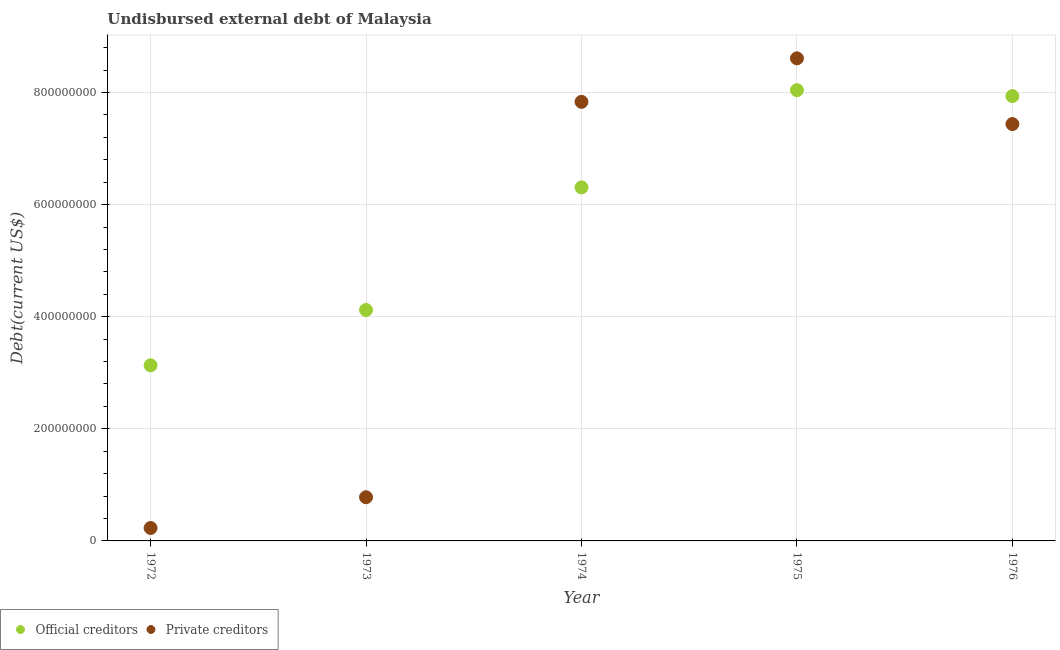Is the number of dotlines equal to the number of legend labels?
Keep it short and to the point. Yes. What is the undisbursed external debt of private creditors in 1974?
Make the answer very short. 7.83e+08. Across all years, what is the maximum undisbursed external debt of official creditors?
Provide a short and direct response. 8.04e+08. Across all years, what is the minimum undisbursed external debt of private creditors?
Keep it short and to the point. 2.31e+07. In which year was the undisbursed external debt of private creditors maximum?
Ensure brevity in your answer.  1975. In which year was the undisbursed external debt of private creditors minimum?
Provide a succinct answer. 1972. What is the total undisbursed external debt of official creditors in the graph?
Ensure brevity in your answer.  2.95e+09. What is the difference between the undisbursed external debt of official creditors in 1972 and that in 1975?
Ensure brevity in your answer.  -4.91e+08. What is the difference between the undisbursed external debt of official creditors in 1974 and the undisbursed external debt of private creditors in 1976?
Ensure brevity in your answer.  -1.13e+08. What is the average undisbursed external debt of official creditors per year?
Offer a terse response. 5.91e+08. In the year 1973, what is the difference between the undisbursed external debt of private creditors and undisbursed external debt of official creditors?
Your answer should be very brief. -3.34e+08. What is the ratio of the undisbursed external debt of official creditors in 1972 to that in 1975?
Keep it short and to the point. 0.39. Is the difference between the undisbursed external debt of official creditors in 1973 and 1975 greater than the difference between the undisbursed external debt of private creditors in 1973 and 1975?
Ensure brevity in your answer.  Yes. What is the difference between the highest and the second highest undisbursed external debt of official creditors?
Your response must be concise. 1.06e+07. What is the difference between the highest and the lowest undisbursed external debt of official creditors?
Offer a very short reply. 4.91e+08. In how many years, is the undisbursed external debt of private creditors greater than the average undisbursed external debt of private creditors taken over all years?
Make the answer very short. 3. Is the sum of the undisbursed external debt of official creditors in 1975 and 1976 greater than the maximum undisbursed external debt of private creditors across all years?
Offer a very short reply. Yes. Does the undisbursed external debt of private creditors monotonically increase over the years?
Provide a short and direct response. No. Is the undisbursed external debt of private creditors strictly less than the undisbursed external debt of official creditors over the years?
Offer a terse response. No. How many dotlines are there?
Offer a very short reply. 2. What is the difference between two consecutive major ticks on the Y-axis?
Your response must be concise. 2.00e+08. Does the graph contain grids?
Make the answer very short. Yes. How many legend labels are there?
Your answer should be very brief. 2. What is the title of the graph?
Provide a succinct answer. Undisbursed external debt of Malaysia. What is the label or title of the Y-axis?
Ensure brevity in your answer.  Debt(current US$). What is the Debt(current US$) in Official creditors in 1972?
Your answer should be very brief. 3.13e+08. What is the Debt(current US$) of Private creditors in 1972?
Provide a succinct answer. 2.31e+07. What is the Debt(current US$) in Official creditors in 1973?
Provide a short and direct response. 4.12e+08. What is the Debt(current US$) in Private creditors in 1973?
Your answer should be very brief. 7.79e+07. What is the Debt(current US$) of Official creditors in 1974?
Your response must be concise. 6.31e+08. What is the Debt(current US$) in Private creditors in 1974?
Provide a short and direct response. 7.83e+08. What is the Debt(current US$) in Official creditors in 1975?
Offer a terse response. 8.04e+08. What is the Debt(current US$) in Private creditors in 1975?
Your answer should be very brief. 8.61e+08. What is the Debt(current US$) in Official creditors in 1976?
Ensure brevity in your answer.  7.94e+08. What is the Debt(current US$) of Private creditors in 1976?
Offer a terse response. 7.44e+08. Across all years, what is the maximum Debt(current US$) of Official creditors?
Offer a terse response. 8.04e+08. Across all years, what is the maximum Debt(current US$) of Private creditors?
Keep it short and to the point. 8.61e+08. Across all years, what is the minimum Debt(current US$) of Official creditors?
Make the answer very short. 3.13e+08. Across all years, what is the minimum Debt(current US$) of Private creditors?
Ensure brevity in your answer.  2.31e+07. What is the total Debt(current US$) in Official creditors in the graph?
Make the answer very short. 2.95e+09. What is the total Debt(current US$) in Private creditors in the graph?
Make the answer very short. 2.49e+09. What is the difference between the Debt(current US$) of Official creditors in 1972 and that in 1973?
Ensure brevity in your answer.  -9.87e+07. What is the difference between the Debt(current US$) of Private creditors in 1972 and that in 1973?
Keep it short and to the point. -5.49e+07. What is the difference between the Debt(current US$) in Official creditors in 1972 and that in 1974?
Make the answer very short. -3.18e+08. What is the difference between the Debt(current US$) of Private creditors in 1972 and that in 1974?
Give a very brief answer. -7.60e+08. What is the difference between the Debt(current US$) in Official creditors in 1972 and that in 1975?
Provide a succinct answer. -4.91e+08. What is the difference between the Debt(current US$) of Private creditors in 1972 and that in 1975?
Ensure brevity in your answer.  -8.38e+08. What is the difference between the Debt(current US$) in Official creditors in 1972 and that in 1976?
Your answer should be very brief. -4.80e+08. What is the difference between the Debt(current US$) in Private creditors in 1972 and that in 1976?
Offer a terse response. -7.21e+08. What is the difference between the Debt(current US$) of Official creditors in 1973 and that in 1974?
Provide a succinct answer. -2.19e+08. What is the difference between the Debt(current US$) in Private creditors in 1973 and that in 1974?
Give a very brief answer. -7.06e+08. What is the difference between the Debt(current US$) in Official creditors in 1973 and that in 1975?
Provide a short and direct response. -3.92e+08. What is the difference between the Debt(current US$) of Private creditors in 1973 and that in 1975?
Ensure brevity in your answer.  -7.83e+08. What is the difference between the Debt(current US$) in Official creditors in 1973 and that in 1976?
Offer a very short reply. -3.82e+08. What is the difference between the Debt(current US$) in Private creditors in 1973 and that in 1976?
Your response must be concise. -6.66e+08. What is the difference between the Debt(current US$) in Official creditors in 1974 and that in 1975?
Keep it short and to the point. -1.73e+08. What is the difference between the Debt(current US$) in Private creditors in 1974 and that in 1975?
Your answer should be compact. -7.76e+07. What is the difference between the Debt(current US$) in Official creditors in 1974 and that in 1976?
Ensure brevity in your answer.  -1.63e+08. What is the difference between the Debt(current US$) in Private creditors in 1974 and that in 1976?
Give a very brief answer. 3.96e+07. What is the difference between the Debt(current US$) of Official creditors in 1975 and that in 1976?
Make the answer very short. 1.06e+07. What is the difference between the Debt(current US$) in Private creditors in 1975 and that in 1976?
Offer a terse response. 1.17e+08. What is the difference between the Debt(current US$) of Official creditors in 1972 and the Debt(current US$) of Private creditors in 1973?
Your response must be concise. 2.35e+08. What is the difference between the Debt(current US$) in Official creditors in 1972 and the Debt(current US$) in Private creditors in 1974?
Your answer should be very brief. -4.70e+08. What is the difference between the Debt(current US$) in Official creditors in 1972 and the Debt(current US$) in Private creditors in 1975?
Provide a short and direct response. -5.48e+08. What is the difference between the Debt(current US$) in Official creditors in 1972 and the Debt(current US$) in Private creditors in 1976?
Make the answer very short. -4.30e+08. What is the difference between the Debt(current US$) of Official creditors in 1973 and the Debt(current US$) of Private creditors in 1974?
Make the answer very short. -3.71e+08. What is the difference between the Debt(current US$) of Official creditors in 1973 and the Debt(current US$) of Private creditors in 1975?
Your answer should be very brief. -4.49e+08. What is the difference between the Debt(current US$) of Official creditors in 1973 and the Debt(current US$) of Private creditors in 1976?
Your answer should be compact. -3.32e+08. What is the difference between the Debt(current US$) of Official creditors in 1974 and the Debt(current US$) of Private creditors in 1975?
Provide a short and direct response. -2.30e+08. What is the difference between the Debt(current US$) in Official creditors in 1974 and the Debt(current US$) in Private creditors in 1976?
Ensure brevity in your answer.  -1.13e+08. What is the difference between the Debt(current US$) in Official creditors in 1975 and the Debt(current US$) in Private creditors in 1976?
Your answer should be very brief. 6.05e+07. What is the average Debt(current US$) in Official creditors per year?
Your answer should be very brief. 5.91e+08. What is the average Debt(current US$) of Private creditors per year?
Provide a succinct answer. 4.98e+08. In the year 1972, what is the difference between the Debt(current US$) in Official creditors and Debt(current US$) in Private creditors?
Your answer should be compact. 2.90e+08. In the year 1973, what is the difference between the Debt(current US$) of Official creditors and Debt(current US$) of Private creditors?
Give a very brief answer. 3.34e+08. In the year 1974, what is the difference between the Debt(current US$) of Official creditors and Debt(current US$) of Private creditors?
Your response must be concise. -1.53e+08. In the year 1975, what is the difference between the Debt(current US$) in Official creditors and Debt(current US$) in Private creditors?
Ensure brevity in your answer.  -5.68e+07. In the year 1976, what is the difference between the Debt(current US$) of Official creditors and Debt(current US$) of Private creditors?
Make the answer very short. 4.99e+07. What is the ratio of the Debt(current US$) of Official creditors in 1972 to that in 1973?
Keep it short and to the point. 0.76. What is the ratio of the Debt(current US$) in Private creditors in 1972 to that in 1973?
Offer a terse response. 0.3. What is the ratio of the Debt(current US$) in Official creditors in 1972 to that in 1974?
Provide a short and direct response. 0.5. What is the ratio of the Debt(current US$) in Private creditors in 1972 to that in 1974?
Your answer should be compact. 0.03. What is the ratio of the Debt(current US$) of Official creditors in 1972 to that in 1975?
Your response must be concise. 0.39. What is the ratio of the Debt(current US$) in Private creditors in 1972 to that in 1975?
Give a very brief answer. 0.03. What is the ratio of the Debt(current US$) in Official creditors in 1972 to that in 1976?
Your answer should be very brief. 0.39. What is the ratio of the Debt(current US$) of Private creditors in 1972 to that in 1976?
Give a very brief answer. 0.03. What is the ratio of the Debt(current US$) in Official creditors in 1973 to that in 1974?
Your answer should be very brief. 0.65. What is the ratio of the Debt(current US$) of Private creditors in 1973 to that in 1974?
Ensure brevity in your answer.  0.1. What is the ratio of the Debt(current US$) of Official creditors in 1973 to that in 1975?
Your answer should be very brief. 0.51. What is the ratio of the Debt(current US$) of Private creditors in 1973 to that in 1975?
Offer a very short reply. 0.09. What is the ratio of the Debt(current US$) of Official creditors in 1973 to that in 1976?
Keep it short and to the point. 0.52. What is the ratio of the Debt(current US$) in Private creditors in 1973 to that in 1976?
Your answer should be compact. 0.1. What is the ratio of the Debt(current US$) of Official creditors in 1974 to that in 1975?
Your answer should be very brief. 0.78. What is the ratio of the Debt(current US$) of Private creditors in 1974 to that in 1975?
Your response must be concise. 0.91. What is the ratio of the Debt(current US$) in Official creditors in 1974 to that in 1976?
Offer a very short reply. 0.79. What is the ratio of the Debt(current US$) of Private creditors in 1974 to that in 1976?
Your response must be concise. 1.05. What is the ratio of the Debt(current US$) in Official creditors in 1975 to that in 1976?
Your answer should be compact. 1.01. What is the ratio of the Debt(current US$) of Private creditors in 1975 to that in 1976?
Keep it short and to the point. 1.16. What is the difference between the highest and the second highest Debt(current US$) in Official creditors?
Your answer should be very brief. 1.06e+07. What is the difference between the highest and the second highest Debt(current US$) in Private creditors?
Offer a terse response. 7.76e+07. What is the difference between the highest and the lowest Debt(current US$) in Official creditors?
Provide a short and direct response. 4.91e+08. What is the difference between the highest and the lowest Debt(current US$) in Private creditors?
Keep it short and to the point. 8.38e+08. 